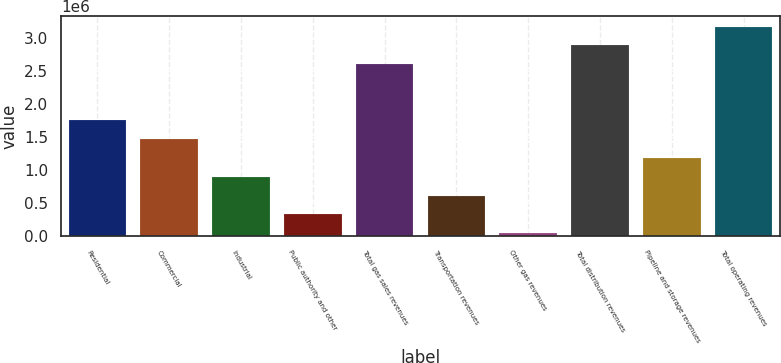Convert chart to OTSL. <chart><loc_0><loc_0><loc_500><loc_500><bar_chart><fcel>Residential<fcel>Commercial<fcel>Industrial<fcel>Public authority and other<fcel>Total gas sales revenues<fcel>Transportation revenues<fcel>Other gas revenues<fcel>Total distribution revenues<fcel>Pipeline and storage revenues<fcel>Total operating revenues<nl><fcel>1.75779e+06<fcel>1.47178e+06<fcel>899747<fcel>327718<fcel>2.60549e+06<fcel>613733<fcel>41704<fcel>2.89151e+06<fcel>1.18576e+06<fcel>3.17752e+06<nl></chart> 